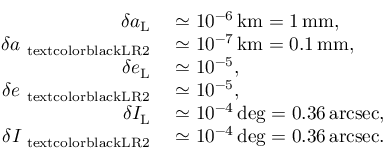Convert formula to latex. <formula><loc_0><loc_0><loc_500><loc_500>\begin{array} { r l } { \delta a _ { L } } & \simeq 1 0 ^ { - 6 } \, k m = 1 \, m m , } \\ { \delta a _ { \ t e x t c o l o r { b l a c k } { L R 2 } } } & \simeq 1 0 ^ { - 7 } \, k m = 0 . 1 \, m m , } \\ { \delta e _ { L } } & \simeq 1 0 ^ { - 5 } , } \\ { \delta e _ { \ t e x t c o l o r { b l a c k } { L R 2 } } } & \simeq 1 0 ^ { - 5 } , } \\ { \delta I _ { L } } & \simeq 1 0 ^ { - 4 } \, d e g = 0 . 3 6 \, a r c s e c , } \\ { \delta I _ { \ t e x t c o l o r { b l a c k } { L R 2 } } } & \simeq 1 0 ^ { - 4 } \, d e g = 0 . 3 6 \, a r c s e c . } \end{array}</formula> 